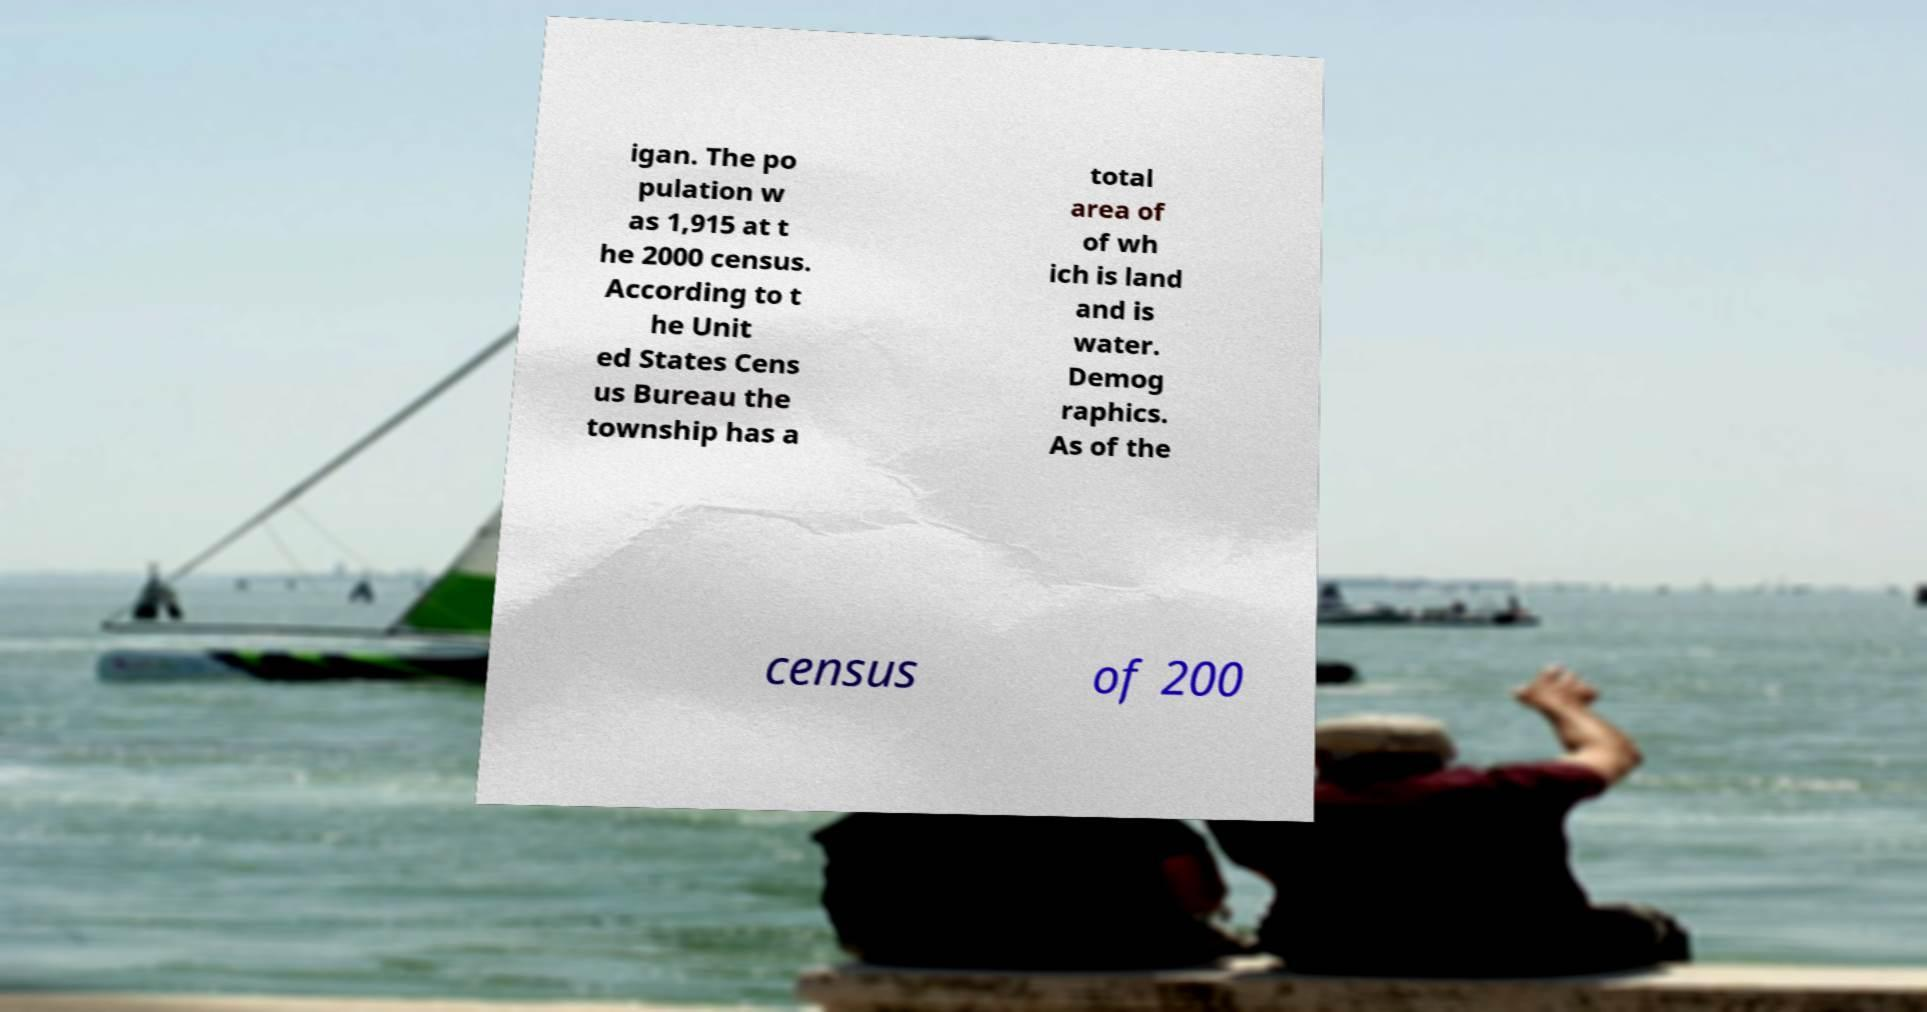Please identify and transcribe the text found in this image. igan. The po pulation w as 1,915 at t he 2000 census. According to t he Unit ed States Cens us Bureau the township has a total area of of wh ich is land and is water. Demog raphics. As of the census of 200 